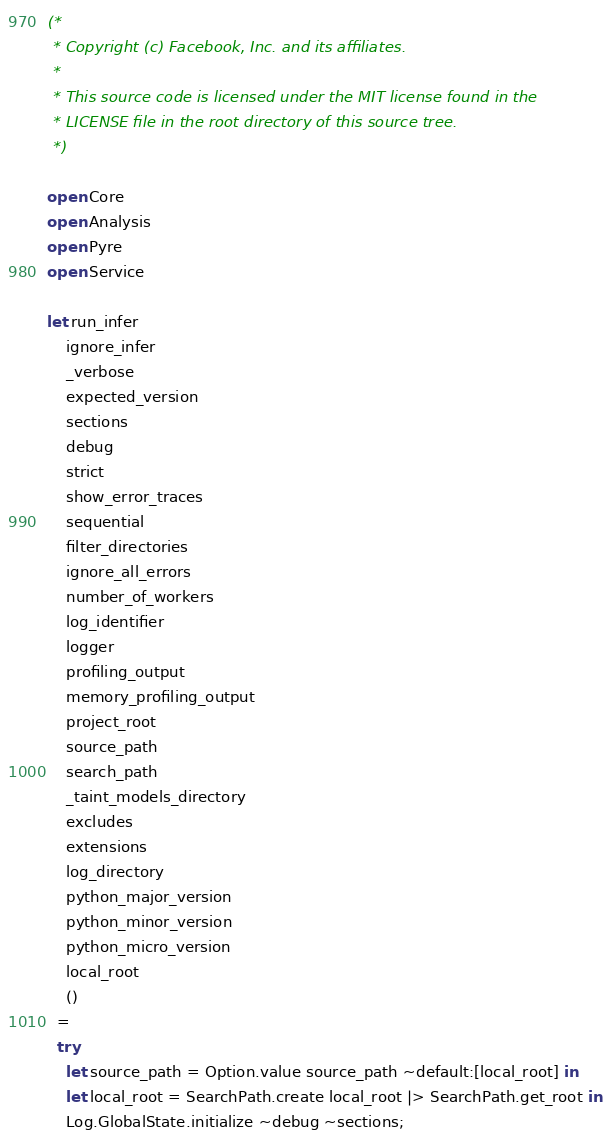<code> <loc_0><loc_0><loc_500><loc_500><_OCaml_>(*
 * Copyright (c) Facebook, Inc. and its affiliates.
 *
 * This source code is licensed under the MIT license found in the
 * LICENSE file in the root directory of this source tree.
 *)

open Core
open Analysis
open Pyre
open Service

let run_infer
    ignore_infer
    _verbose
    expected_version
    sections
    debug
    strict
    show_error_traces
    sequential
    filter_directories
    ignore_all_errors
    number_of_workers
    log_identifier
    logger
    profiling_output
    memory_profiling_output
    project_root
    source_path
    search_path
    _taint_models_directory
    excludes
    extensions
    log_directory
    python_major_version
    python_minor_version
    python_micro_version
    local_root
    ()
  =
  try
    let source_path = Option.value source_path ~default:[local_root] in
    let local_root = SearchPath.create local_root |> SearchPath.get_root in
    Log.GlobalState.initialize ~debug ~sections;</code> 